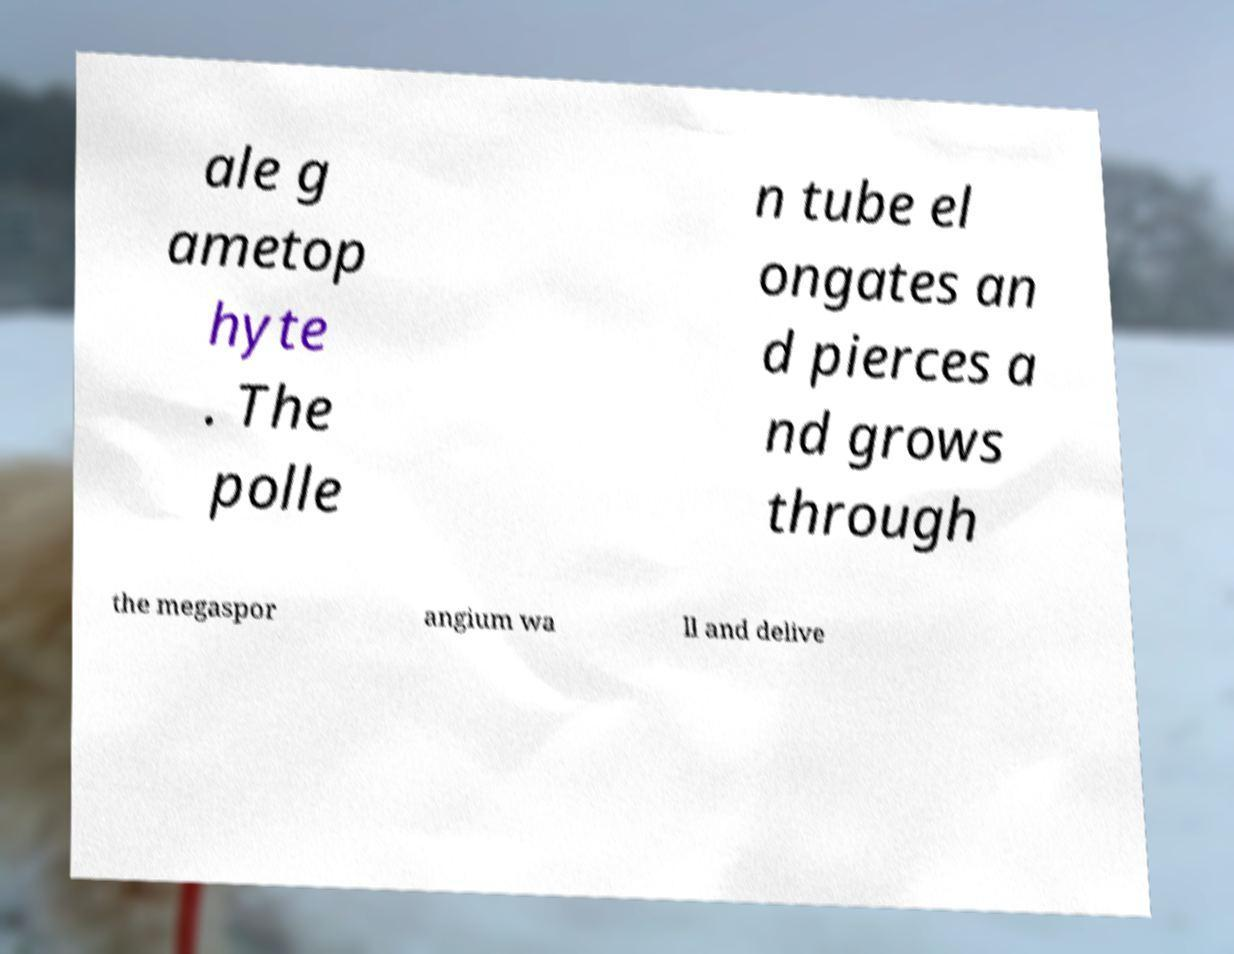I need the written content from this picture converted into text. Can you do that? ale g ametop hyte . The polle n tube el ongates an d pierces a nd grows through the megaspor angium wa ll and delive 